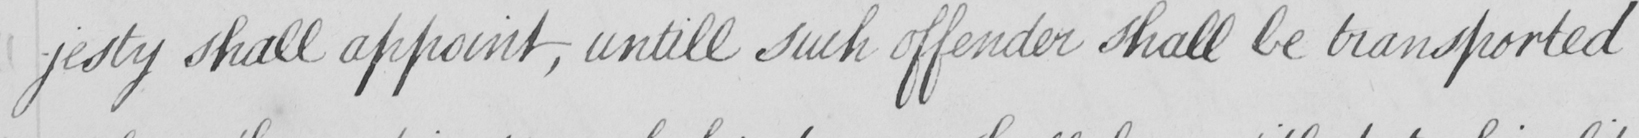Can you read and transcribe this handwriting? -jesty shall appoint , untill such offender shall be transported 